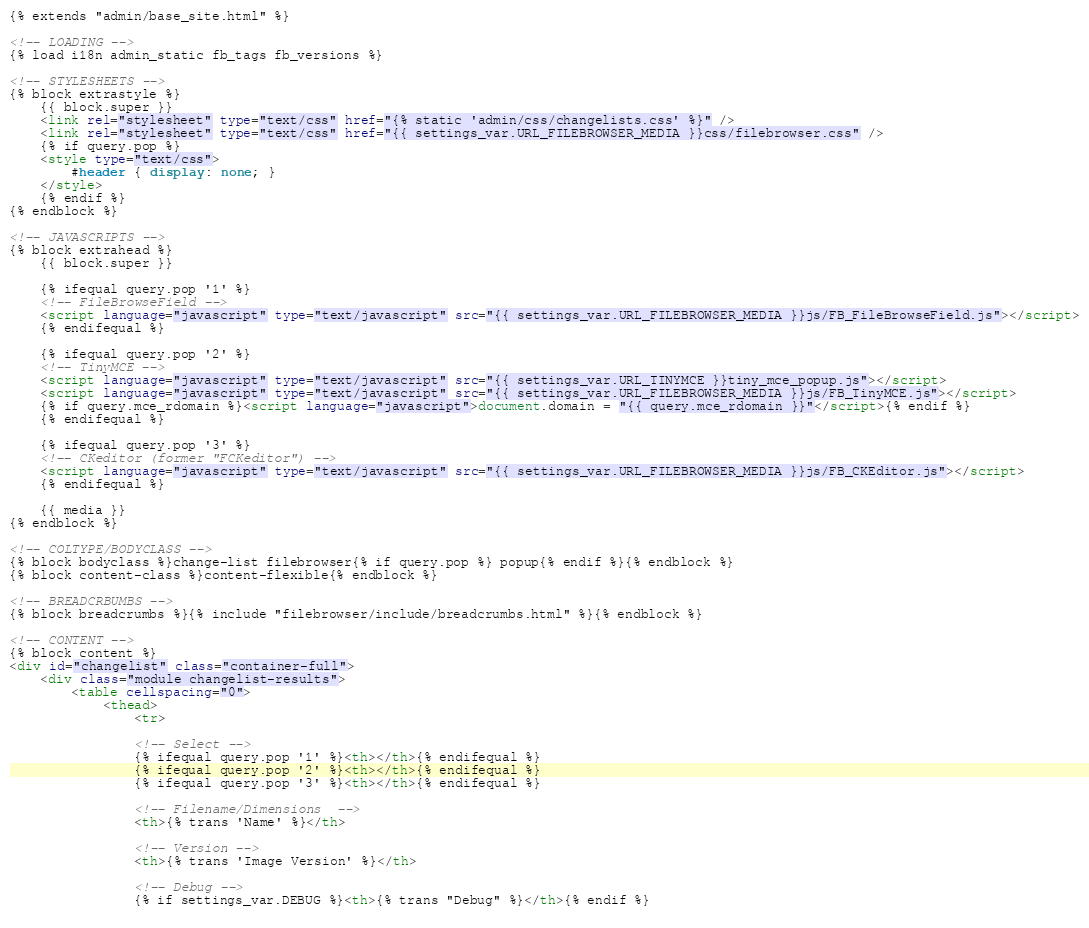<code> <loc_0><loc_0><loc_500><loc_500><_HTML_>{% extends "admin/base_site.html" %}

<!-- LOADING -->
{% load i18n admin_static fb_tags fb_versions %}

<!-- STYLESHEETS -->
{% block extrastyle %}
    {{ block.super }}
    <link rel="stylesheet" type="text/css" href="{% static 'admin/css/changelists.css' %}" />
    <link rel="stylesheet" type="text/css" href="{{ settings_var.URL_FILEBROWSER_MEDIA }}css/filebrowser.css" />
    {% if query.pop %}
    <style type="text/css">
        #header { display: none; }
    </style>
    {% endif %}
{% endblock %}

<!-- JAVASCRIPTS -->
{% block extrahead %}
    {{ block.super }}
    
    {% ifequal query.pop '1' %}
    <!-- FileBrowseField -->
    <script language="javascript" type="text/javascript" src="{{ settings_var.URL_FILEBROWSER_MEDIA }}js/FB_FileBrowseField.js"></script>
    {% endifequal %}
    
    {% ifequal query.pop '2' %}
    <!-- TinyMCE -->
    <script language="javascript" type="text/javascript" src="{{ settings_var.URL_TINYMCE }}tiny_mce_popup.js"></script>
    <script language="javascript" type="text/javascript" src="{{ settings_var.URL_FILEBROWSER_MEDIA }}js/FB_TinyMCE.js"></script>
    {% if query.mce_rdomain %}<script language="javascript">document.domain = "{{ query.mce_rdomain }}"</script>{% endif %}
    {% endifequal %}
    
    {% ifequal query.pop '3' %}
    <!-- CKeditor (former "FCKeditor") -->
    <script language="javascript" type="text/javascript" src="{{ settings_var.URL_FILEBROWSER_MEDIA }}js/FB_CKEditor.js"></script>
    {% endifequal %}
    
    {{ media }}
{% endblock %}

<!-- COLTYPE/BODYCLASS -->
{% block bodyclass %}change-list filebrowser{% if query.pop %} popup{% endif %}{% endblock %}
{% block content-class %}content-flexible{% endblock %}

<!-- BREADCRBUMBS -->
{% block breadcrumbs %}{% include "filebrowser/include/breadcrumbs.html" %}{% endblock %}

<!-- CONTENT -->
{% block content %}
<div id="changelist" class="container-full">
    <div class="module changelist-results">
        <table cellspacing="0">
            <thead>
                <tr>
                
                <!-- Select -->
                {% ifequal query.pop '1' %}<th></th>{% endifequal %}
                {% ifequal query.pop '2' %}<th></th>{% endifequal %}
                {% ifequal query.pop '3' %}<th></th>{% endifequal %}
                
                <!-- Filename/Dimensions  -->
                <th>{% trans 'Name' %}</th>
                
                <!-- Version -->
                <th>{% trans 'Image Version' %}</th>
                
                <!-- Debug -->
                {% if settings_var.DEBUG %}<th>{% trans "Debug" %}</th>{% endif %}
                </code> 